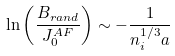<formula> <loc_0><loc_0><loc_500><loc_500>\ln \left ( \frac { B _ { r a n d } } { J ^ { A F } _ { 0 } } \right ) \sim - \frac { 1 } { n _ { i } ^ { 1 / 3 } a }</formula> 